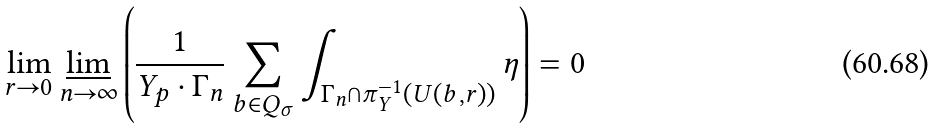Convert formula to latex. <formula><loc_0><loc_0><loc_500><loc_500>\lim _ { r \to 0 } \varliminf _ { n \to \infty } \left ( \frac { 1 } { Y _ { p } \cdot \Gamma _ { n } } \sum _ { b \in Q _ { \sigma } } \int _ { \Gamma _ { n } \cap \pi _ { Y } ^ { - 1 } ( U ( b , r ) ) } \eta \right ) = 0</formula> 